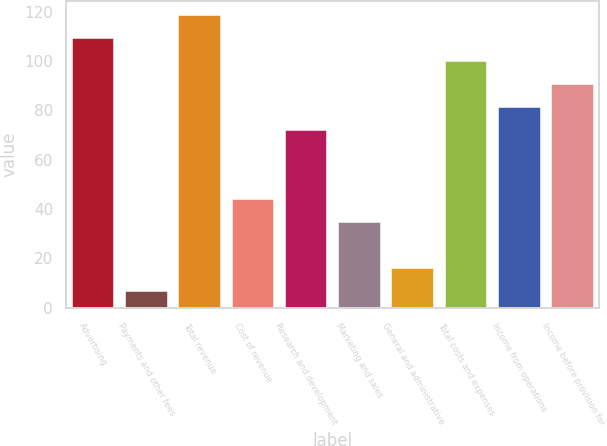Convert chart to OTSL. <chart><loc_0><loc_0><loc_500><loc_500><bar_chart><fcel>Advertising<fcel>Payments and other fees<fcel>Total revenue<fcel>Cost of revenue<fcel>Research and development<fcel>Marketing and sales<fcel>General and administrative<fcel>Total costs and expenses<fcel>Income from operations<fcel>Income before provision for<nl><fcel>109.3<fcel>7<fcel>118.6<fcel>44.2<fcel>72.1<fcel>34.9<fcel>16.3<fcel>100<fcel>81.4<fcel>90.7<nl></chart> 